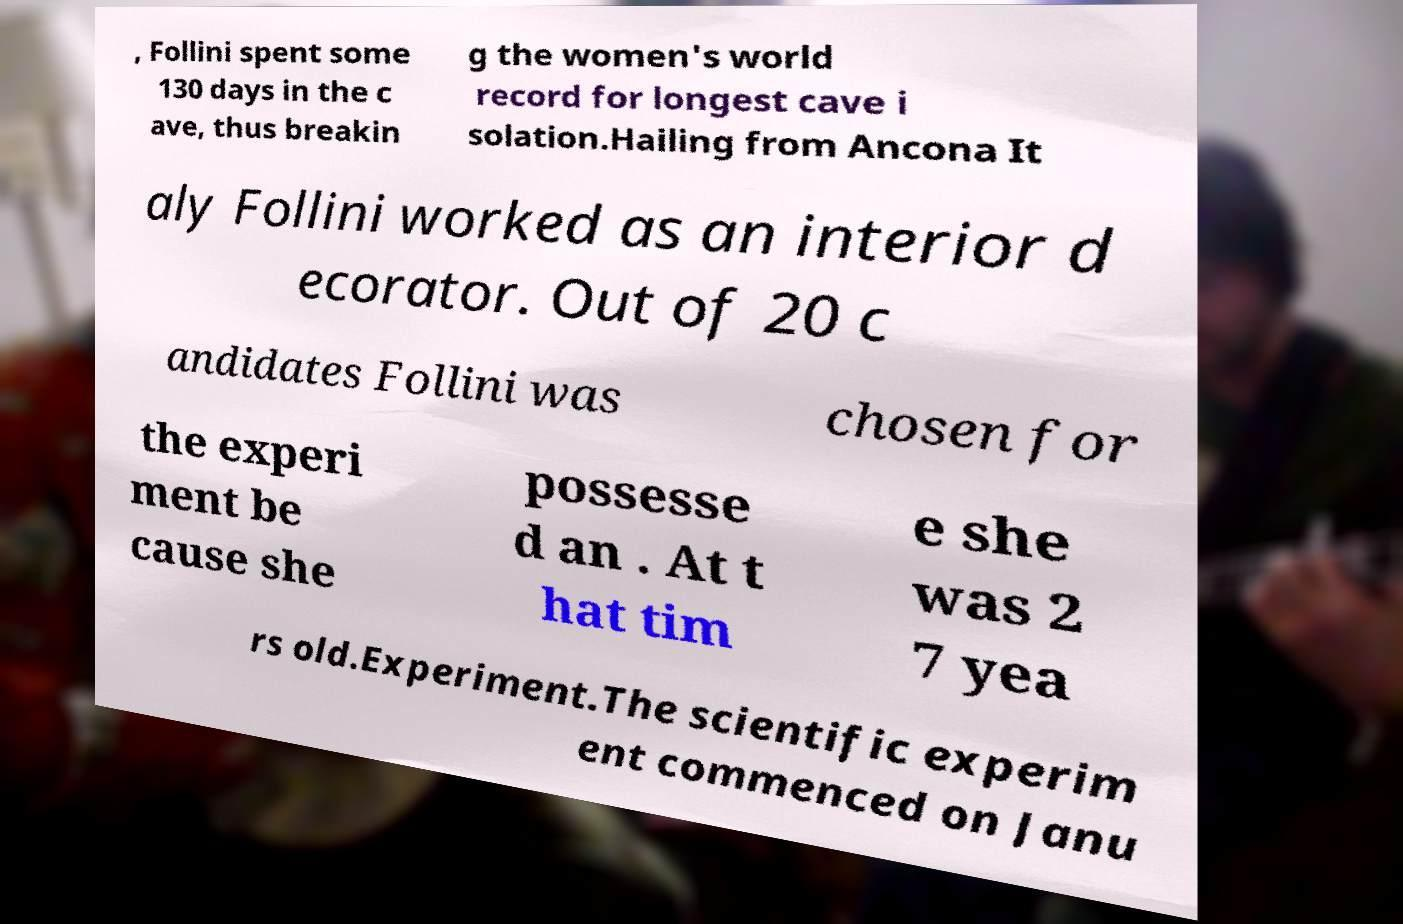What messages or text are displayed in this image? I need them in a readable, typed format. , Follini spent some 130 days in the c ave, thus breakin g the women's world record for longest cave i solation.Hailing from Ancona It aly Follini worked as an interior d ecorator. Out of 20 c andidates Follini was chosen for the experi ment be cause she possesse d an . At t hat tim e she was 2 7 yea rs old.Experiment.The scientific experim ent commenced on Janu 